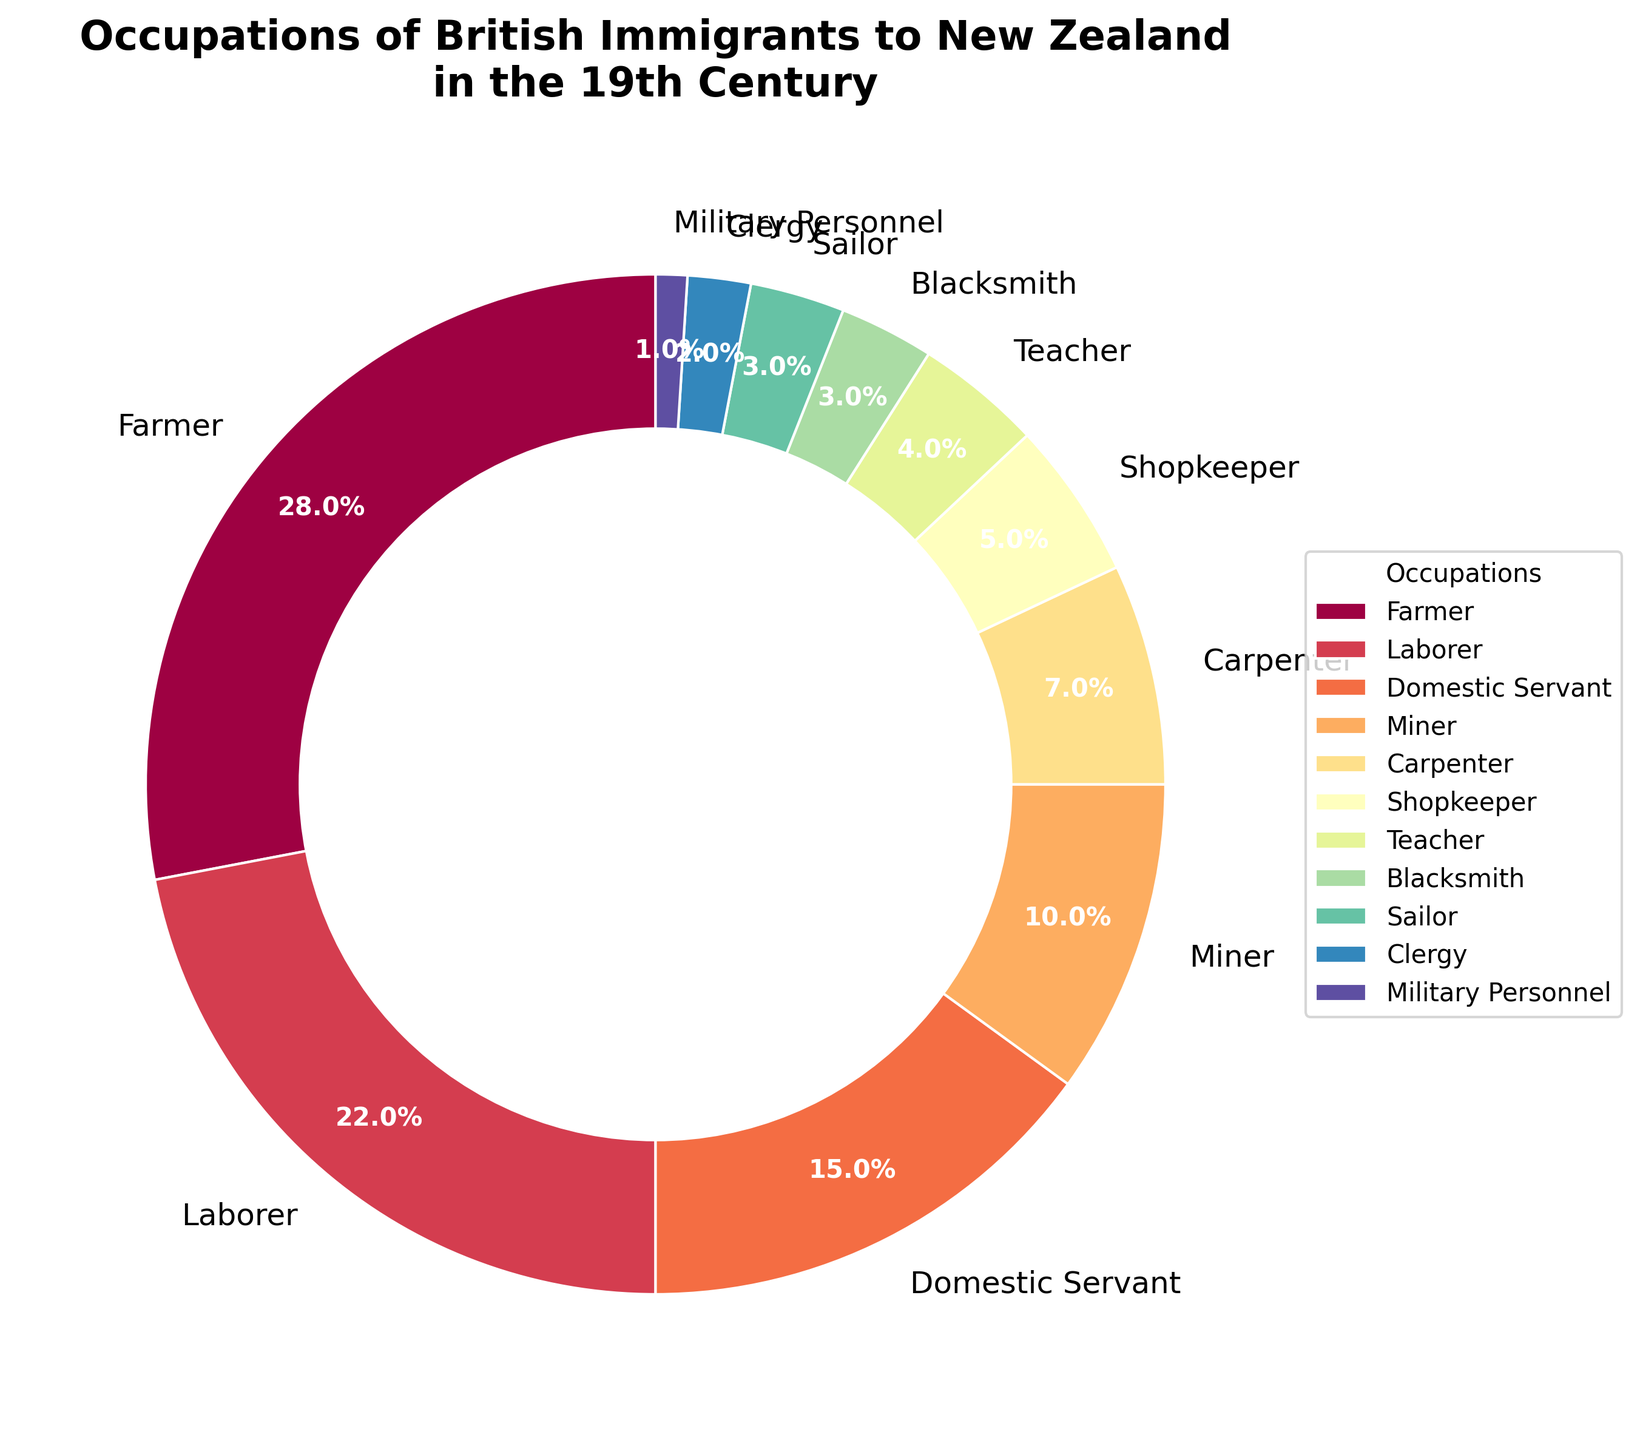Which occupation had the highest percentage among British immigrants to New Zealand in the 19th century? By examining the pie chart, you can easily see that the occupation with the highest percentage is labeled and its corresponding wedge is the largest in the chart.
Answer: Farmer Which two occupations together make up more than half of the British immigrants to New Zealand in the 19th century? To find this, sum the percentages of the two highest occupations. The highest is Farmer at 28%, and the next highest is Laborer at 22%. Adding these gives 28% + 22% = 50%, which is exactly half, so we need to look at both of these individually and confirm they are the sum of more than half. They are not, so look further down the list. The next highest values after these are Domestic Servant (15%), so considering summing of Top 3 (28%+22%+15%) makes 65%. The answer here should be recalculated or just shown below.
Answer: Farmer and Laborer, Other combinations like Top 3 makes up 65% What is the combined percentage of Farmers, Laborers, and Domestic Servants among British immigrants to New Zealand in the 19th century? First, identify the percentages of Farmers, Laborers, and Domestic Servants: 28%, 22%, and 15%, respectively. Add these percentages: 28% + 22% + 15% = 65%.
Answer: 65% Which occupations individually make up less than 5% of the British immigrants to New Zealand in the 19th century? By reviewing the pie chart, look for any wedges labeled with percentages below 5%.
Answer: Blacksmith (3%), Sailor (3%), Clergy (2%), Military Personnel (1%) How does the percentage of Farmers compare to the combined percentage of Miners and Domestic Servants? The percentage of Farmers is 28%. The combined percentage of Miners and Domestic Servants is 10% + 15% = 25%. So, Farmers have a higher percentage than the combined group of Miners and Domestic Servants.
Answer: Farmers (28%) > Miners + Domestic Servants (25%) What is the difference in percentage between Laborers and Carpenters? To find the difference, subtract the percentage of Carpenters (7%) from the percentage of Laborers (22%): 22% - 7% = 15%.
Answer: 15% What percentage of British immigrants were involved in skilled trades (e.g., Carpenter, Blacksmith)? Identify the skilled trades and their corresponding percentages: Carpenter (7%) and Blacksmith (3%). Add these percentages: 7% + 3% = 10%.
Answer: 10% How many different occupations make up 80% of the British immigrants? Sum the percentages of the highest occupations until you reach 80%. Farmers (28%) + Laborers (22%) = 50%; adding Domestic Servants (15%) makes it 65%; adding Miners (10%) makes it 75%; and finally, adding Carpenters (7%) makes it 82%. So it takes 5 occupations to surpass 80%.
Answer: 5 occupations Which occupation has the lowest percentage of British immigrants to New Zealand in the 19th century? By examining the pie chart, you can identify the occupation with the smallest wedge, labeled with the smallest percentage.
Answer: Military Personnel 